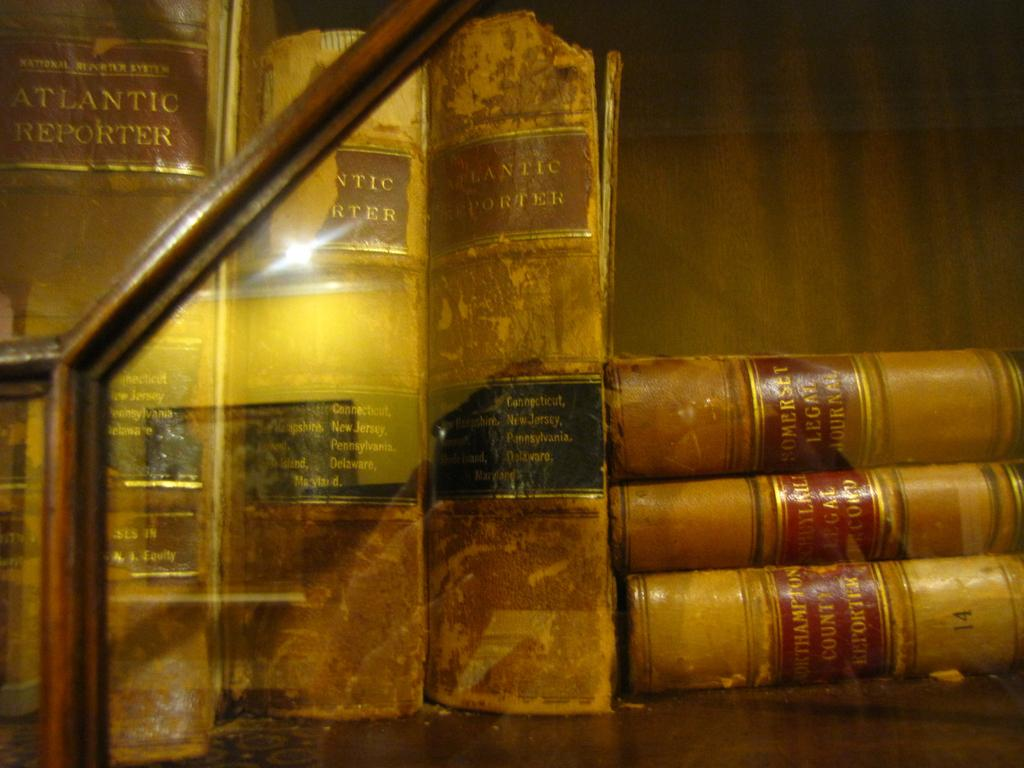<image>
Relay a brief, clear account of the picture shown. Faded and torn covers for the Atlantic Reporter and lined up with some other books laying beside them. 